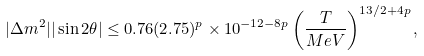<formula> <loc_0><loc_0><loc_500><loc_500>| \Delta m ^ { 2 } | | \sin 2 \theta | \leq 0 . 7 6 ( 2 . 7 5 ) ^ { p } \times 1 0 ^ { - 1 2 - 8 p } \left ( \frac { T } { M e V } \right ) ^ { 1 3 / 2 + 4 p } ,</formula> 